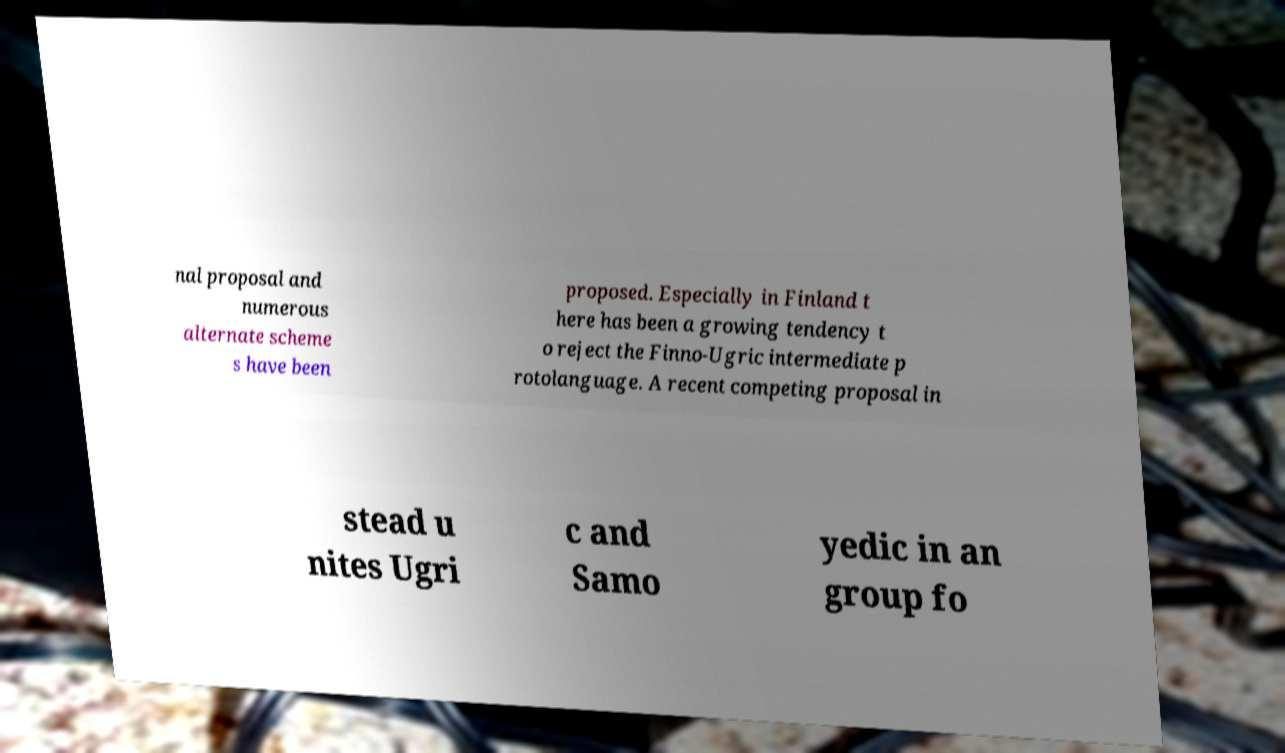For documentation purposes, I need the text within this image transcribed. Could you provide that? nal proposal and numerous alternate scheme s have been proposed. Especially in Finland t here has been a growing tendency t o reject the Finno-Ugric intermediate p rotolanguage. A recent competing proposal in stead u nites Ugri c and Samo yedic in an group fo 